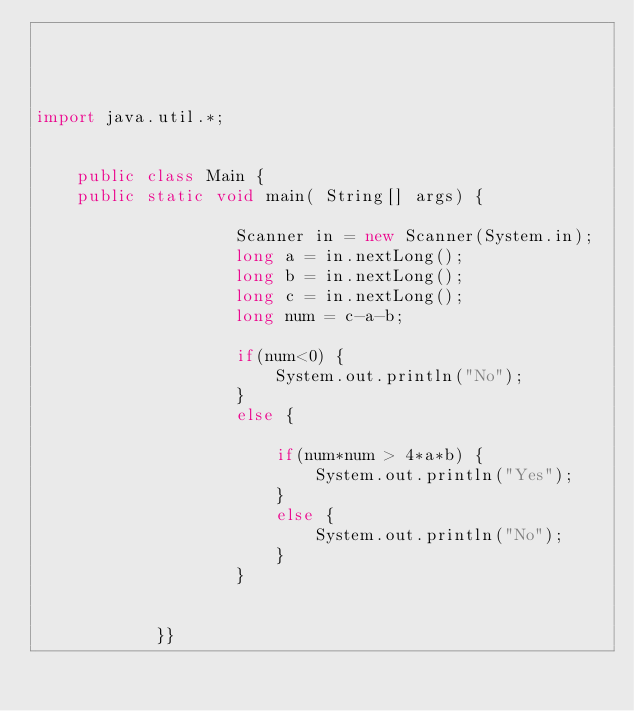Convert code to text. <code><loc_0><loc_0><loc_500><loc_500><_Java_>
	


import java.util.*;


	public class Main {
	public static void main( String[] args) {			
					
					Scanner in = new Scanner(System.in);
					long a = in.nextLong();
					long b = in.nextLong();
					long c = in.nextLong();
					long num = c-a-b;
					
					if(num<0) {
						System.out.println("No");
					}
					else {
					 
						if(num*num > 4*a*b) {
							System.out.println("Yes");
						}
						else {
							System.out.println("No");
						}
					}
		
					
			}}</code> 